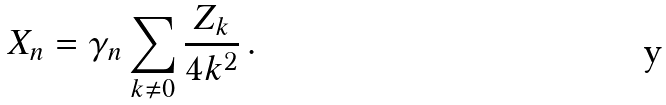Convert formula to latex. <formula><loc_0><loc_0><loc_500><loc_500>X _ { n } = \gamma _ { n } \sum _ { k \neq 0 } \frac { Z _ { k } } { 4 k ^ { 2 } } \, .</formula> 